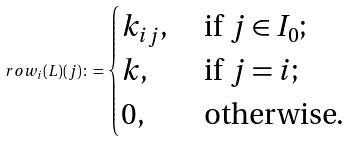<formula> <loc_0><loc_0><loc_500><loc_500>\ r o w _ { i } ( L ) ( j ) \colon = \begin{cases} k _ { i j } , & \text { if $j\in I_{0}$;} \\ k , & \text { if $j=i$;} \\ 0 , & \text { otherwise.} \end{cases}</formula> 